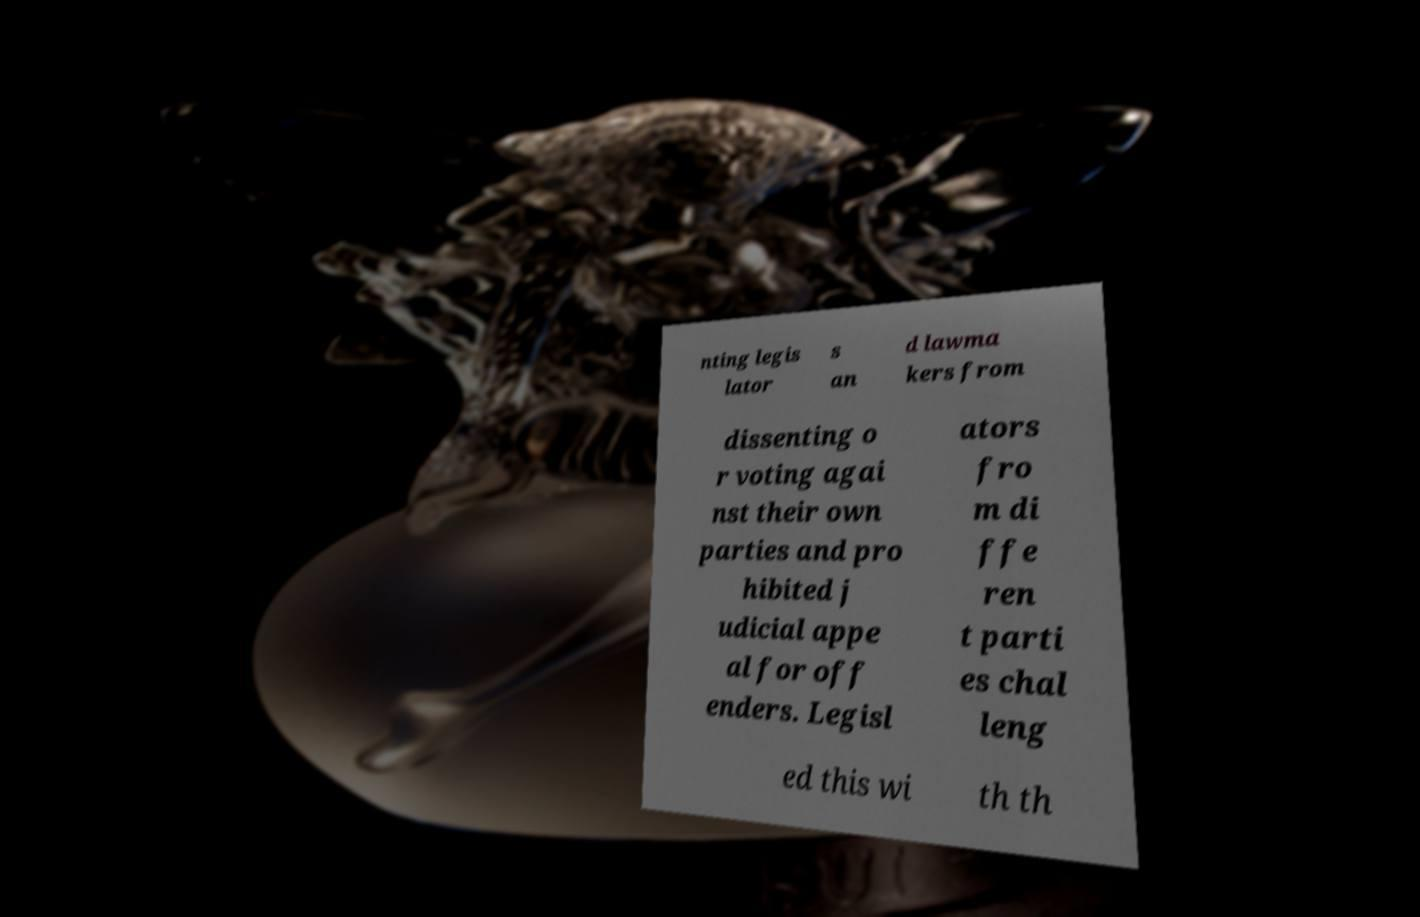Please read and relay the text visible in this image. What does it say? nting legis lator s an d lawma kers from dissenting o r voting agai nst their own parties and pro hibited j udicial appe al for off enders. Legisl ators fro m di ffe ren t parti es chal leng ed this wi th th 